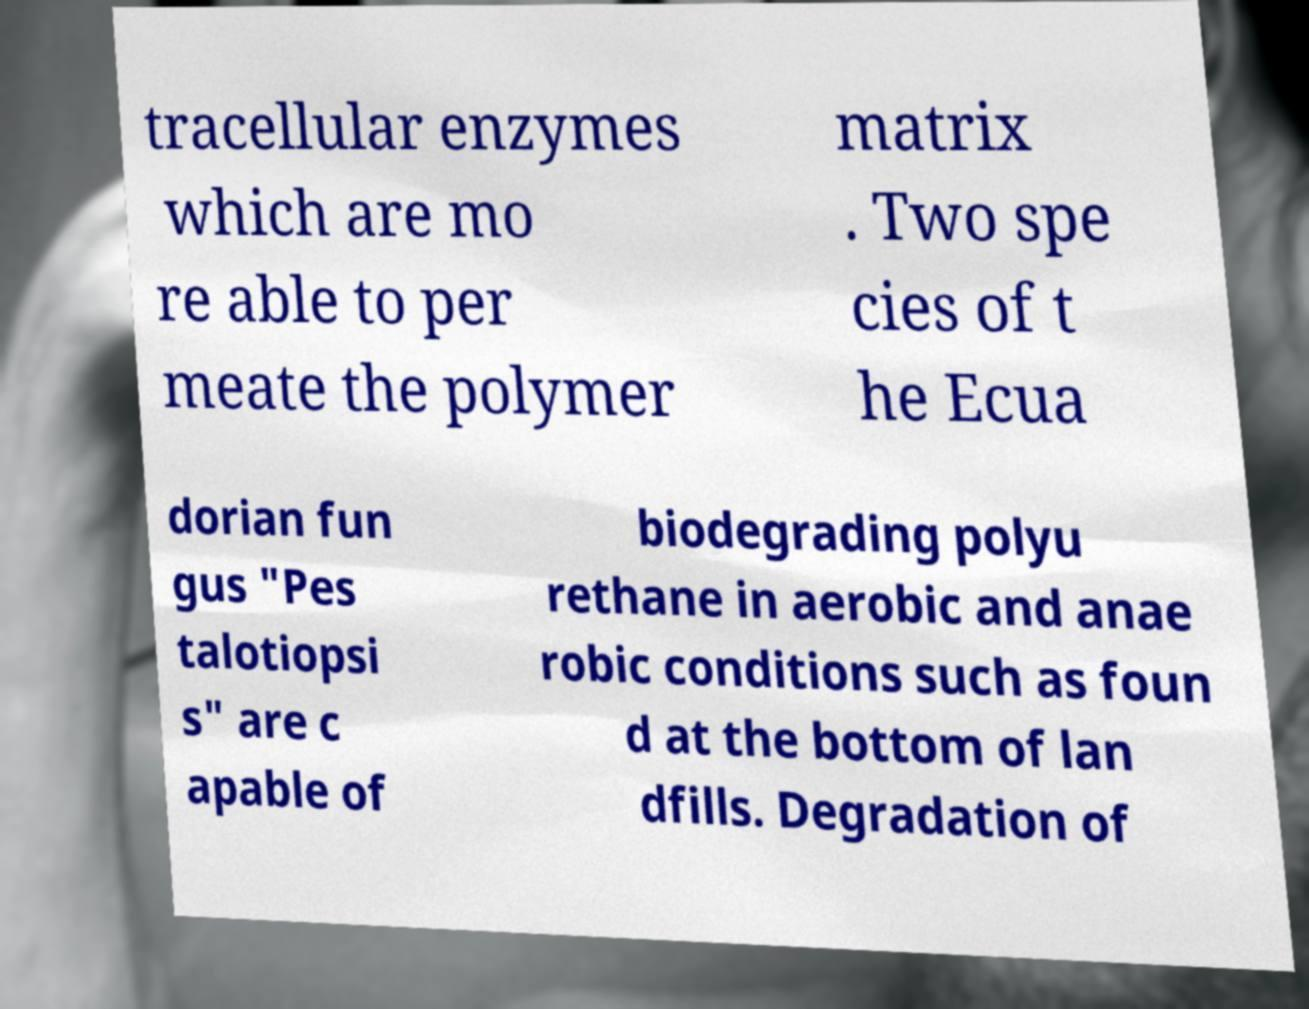Please read and relay the text visible in this image. What does it say? tracellular enzymes which are mo re able to per meate the polymer matrix . Two spe cies of t he Ecua dorian fun gus "Pes talotiopsi s" are c apable of biodegrading polyu rethane in aerobic and anae robic conditions such as foun d at the bottom of lan dfills. Degradation of 